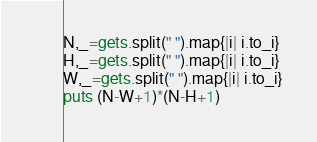Convert code to text. <code><loc_0><loc_0><loc_500><loc_500><_Ruby_>N,_=gets.split(" ").map{|i| i.to_i}
H,_=gets.split(" ").map{|i| i.to_i}
W,_=gets.split(" ").map{|i| i.to_i}
puts (N-W+1)*(N-H+1)

</code> 